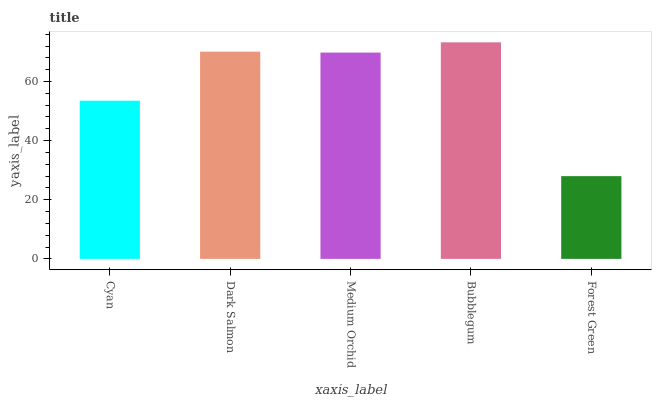Is Forest Green the minimum?
Answer yes or no. Yes. Is Bubblegum the maximum?
Answer yes or no. Yes. Is Dark Salmon the minimum?
Answer yes or no. No. Is Dark Salmon the maximum?
Answer yes or no. No. Is Dark Salmon greater than Cyan?
Answer yes or no. Yes. Is Cyan less than Dark Salmon?
Answer yes or no. Yes. Is Cyan greater than Dark Salmon?
Answer yes or no. No. Is Dark Salmon less than Cyan?
Answer yes or no. No. Is Medium Orchid the high median?
Answer yes or no. Yes. Is Medium Orchid the low median?
Answer yes or no. Yes. Is Forest Green the high median?
Answer yes or no. No. Is Bubblegum the low median?
Answer yes or no. No. 